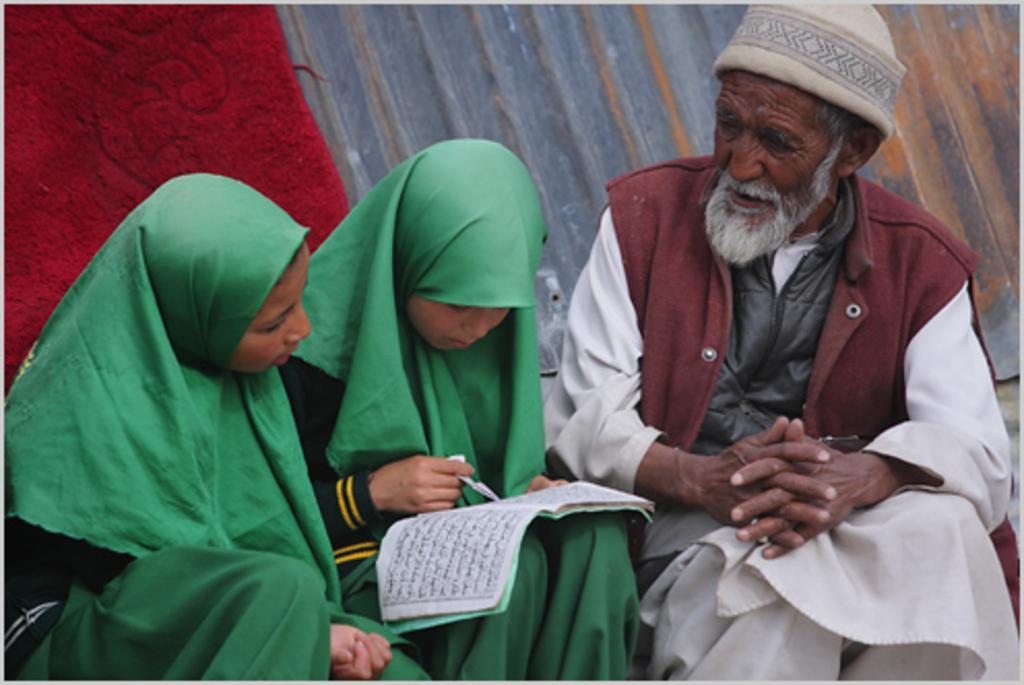In one or two sentences, can you explain what this image depicts? In this picture there is a kid wearing green dress is sitting and holding a book in her hand and there are two persons sitting on either sides of her and there is a red cloth and some other object in the background. 